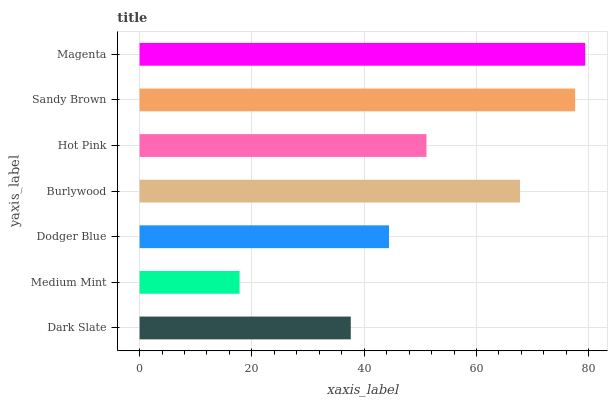Is Medium Mint the minimum?
Answer yes or no. Yes. Is Magenta the maximum?
Answer yes or no. Yes. Is Dodger Blue the minimum?
Answer yes or no. No. Is Dodger Blue the maximum?
Answer yes or no. No. Is Dodger Blue greater than Medium Mint?
Answer yes or no. Yes. Is Medium Mint less than Dodger Blue?
Answer yes or no. Yes. Is Medium Mint greater than Dodger Blue?
Answer yes or no. No. Is Dodger Blue less than Medium Mint?
Answer yes or no. No. Is Hot Pink the high median?
Answer yes or no. Yes. Is Hot Pink the low median?
Answer yes or no. Yes. Is Medium Mint the high median?
Answer yes or no. No. Is Burlywood the low median?
Answer yes or no. No. 